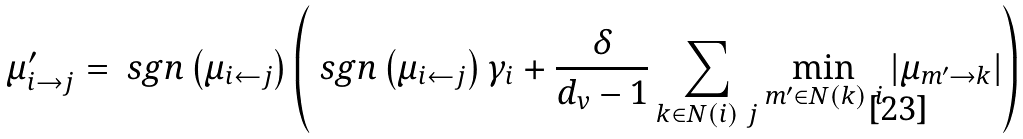<formula> <loc_0><loc_0><loc_500><loc_500>\mu _ { i \rightarrow j } ^ { \prime } & = \ s g n \left ( \mu _ { i \leftarrow j } \right ) \left ( \ s g n \left ( \mu _ { i \leftarrow j } \right ) \gamma _ { i } + \frac { \delta } { d _ { v } - 1 } \sum _ { k \in N ( i ) \ j } \min _ { m ^ { \prime } \in N ( k ) \ i } \left | \mu _ { m ^ { \prime } \rightarrow k } \right | \right )</formula> 